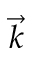<formula> <loc_0><loc_0><loc_500><loc_500>\vec { k }</formula> 